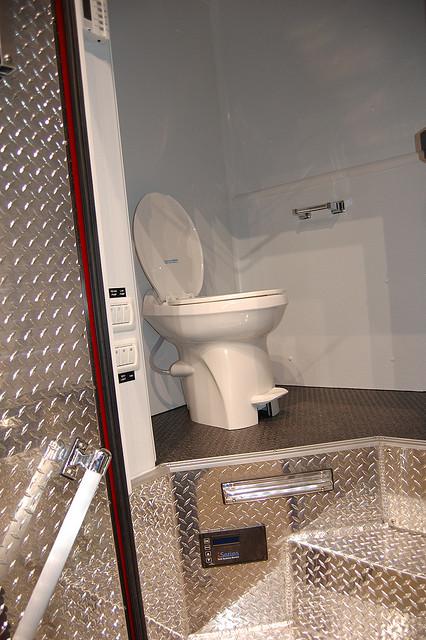Is the lid up or down?
Write a very short answer. Up. Is this in a motorized vehicle?
Answer briefly. Yes. Is this outhouse clean?
Give a very brief answer. Yes. Is there a sink in the image?
Write a very short answer. No. 